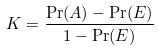Convert formula to latex. <formula><loc_0><loc_0><loc_500><loc_500>K = \frac { \Pr ( A ) - \Pr ( E ) } { 1 - \Pr ( E ) }</formula> 